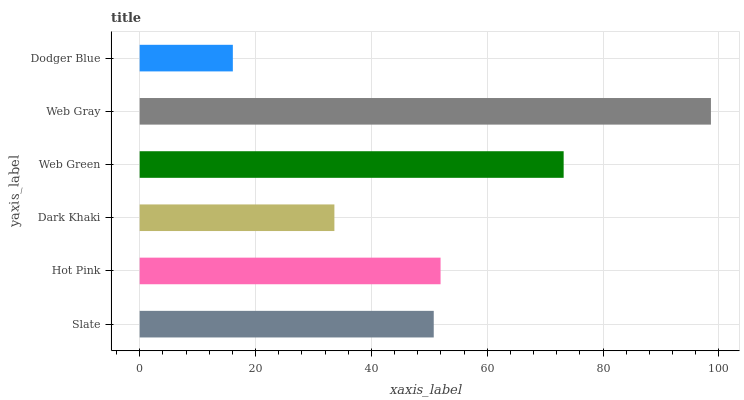Is Dodger Blue the minimum?
Answer yes or no. Yes. Is Web Gray the maximum?
Answer yes or no. Yes. Is Hot Pink the minimum?
Answer yes or no. No. Is Hot Pink the maximum?
Answer yes or no. No. Is Hot Pink greater than Slate?
Answer yes or no. Yes. Is Slate less than Hot Pink?
Answer yes or no. Yes. Is Slate greater than Hot Pink?
Answer yes or no. No. Is Hot Pink less than Slate?
Answer yes or no. No. Is Hot Pink the high median?
Answer yes or no. Yes. Is Slate the low median?
Answer yes or no. Yes. Is Web Gray the high median?
Answer yes or no. No. Is Hot Pink the low median?
Answer yes or no. No. 